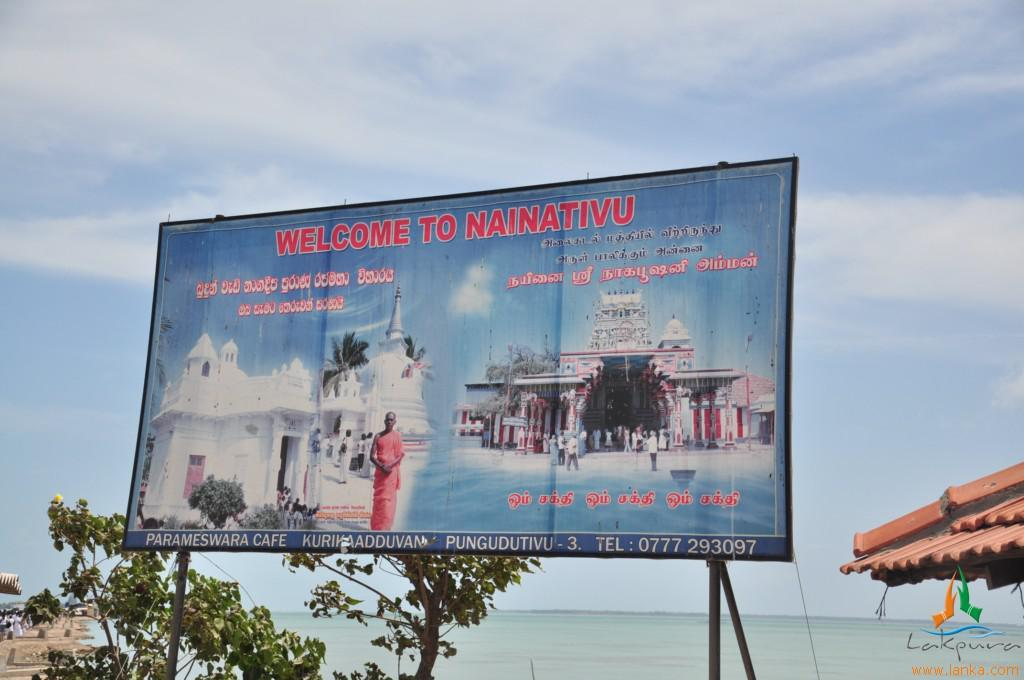<image>
Render a clear and concise summary of the photo. A large sign next to a body of water that reads WELCOME TO NAINATIVU. 